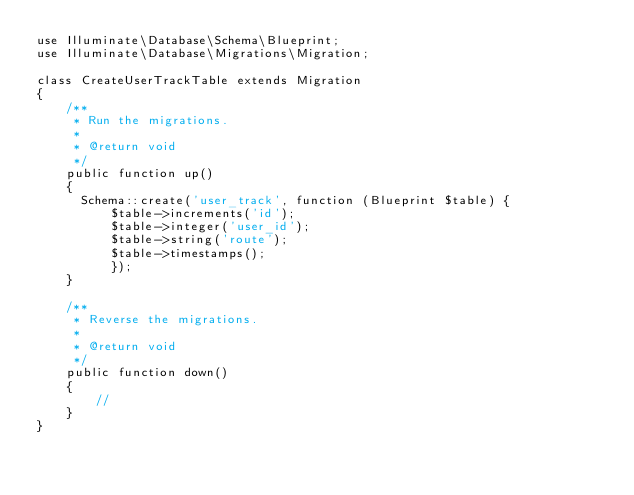<code> <loc_0><loc_0><loc_500><loc_500><_PHP_>use Illuminate\Database\Schema\Blueprint;
use Illuminate\Database\Migrations\Migration;

class CreateUserTrackTable extends Migration
{
    /**
     * Run the migrations.
     *
     * @return void
     */
    public function up()
    {
      Schema::create('user_track', function (Blueprint $table) {
          $table->increments('id');
          $table->integer('user_id');
          $table->string('route');
          $table->timestamps();
          });
    }

    /**
     * Reverse the migrations.
     *
     * @return void
     */
    public function down()
    {
        //
    }
}
</code> 